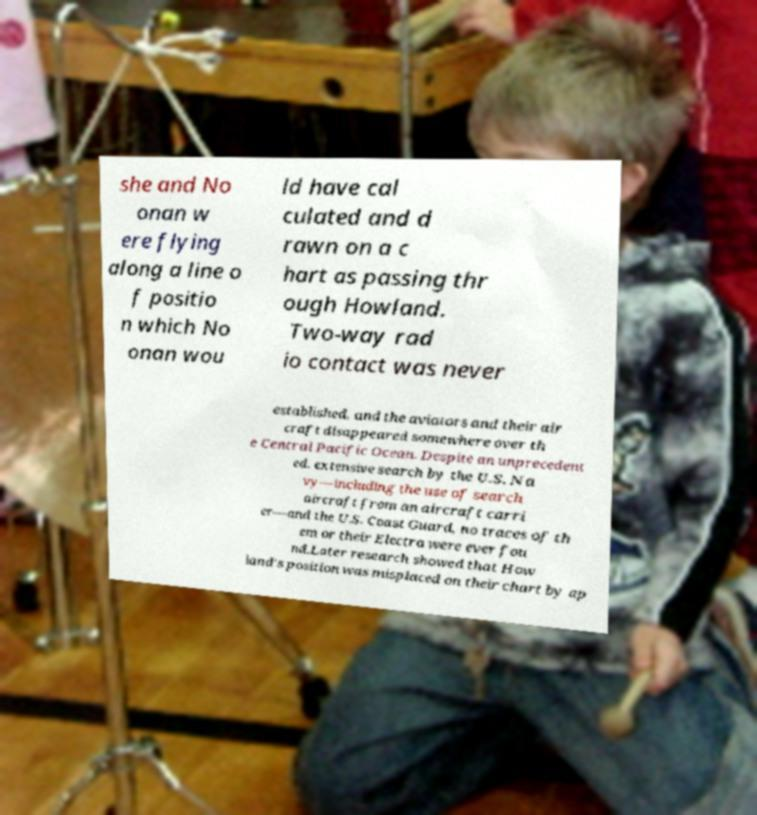There's text embedded in this image that I need extracted. Can you transcribe it verbatim? she and No onan w ere flying along a line o f positio n which No onan wou ld have cal culated and d rawn on a c hart as passing thr ough Howland. Two-way rad io contact was never established, and the aviators and their air craft disappeared somewhere over th e Central Pacific Ocean. Despite an unprecedent ed, extensive search by the U.S. Na vy—including the use of search aircraft from an aircraft carri er—and the U.S. Coast Guard, no traces of th em or their Electra were ever fou nd.Later research showed that How land's position was misplaced on their chart by ap 